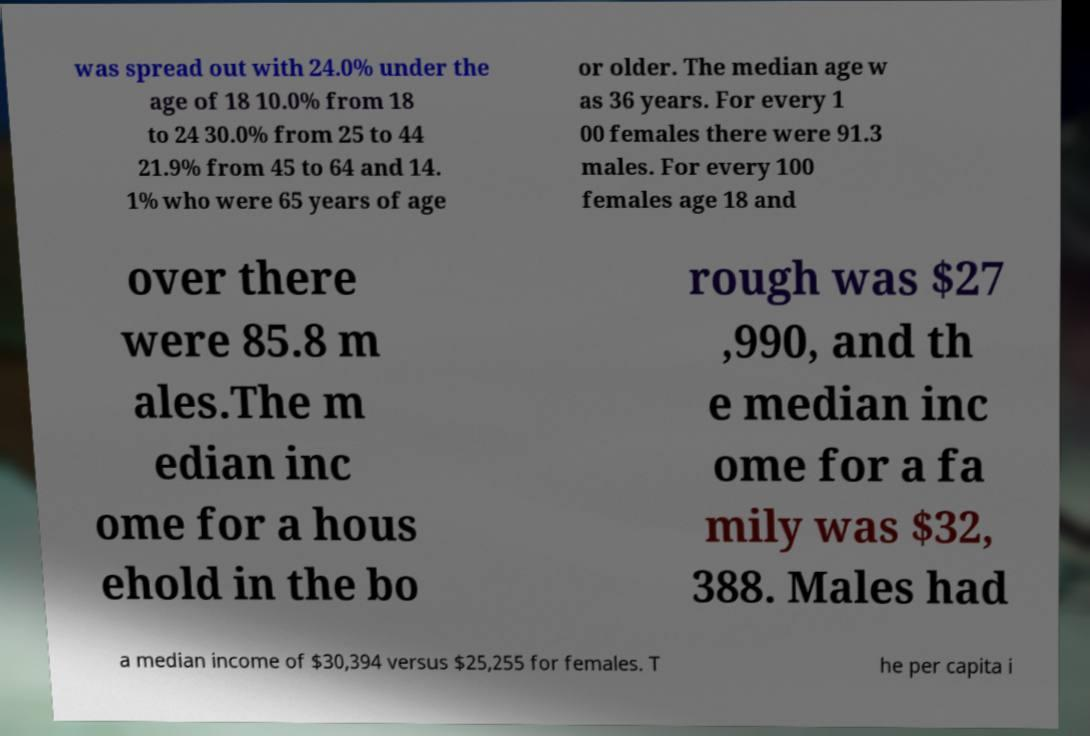For documentation purposes, I need the text within this image transcribed. Could you provide that? was spread out with 24.0% under the age of 18 10.0% from 18 to 24 30.0% from 25 to 44 21.9% from 45 to 64 and 14. 1% who were 65 years of age or older. The median age w as 36 years. For every 1 00 females there were 91.3 males. For every 100 females age 18 and over there were 85.8 m ales.The m edian inc ome for a hous ehold in the bo rough was $27 ,990, and th e median inc ome for a fa mily was $32, 388. Males had a median income of $30,394 versus $25,255 for females. T he per capita i 